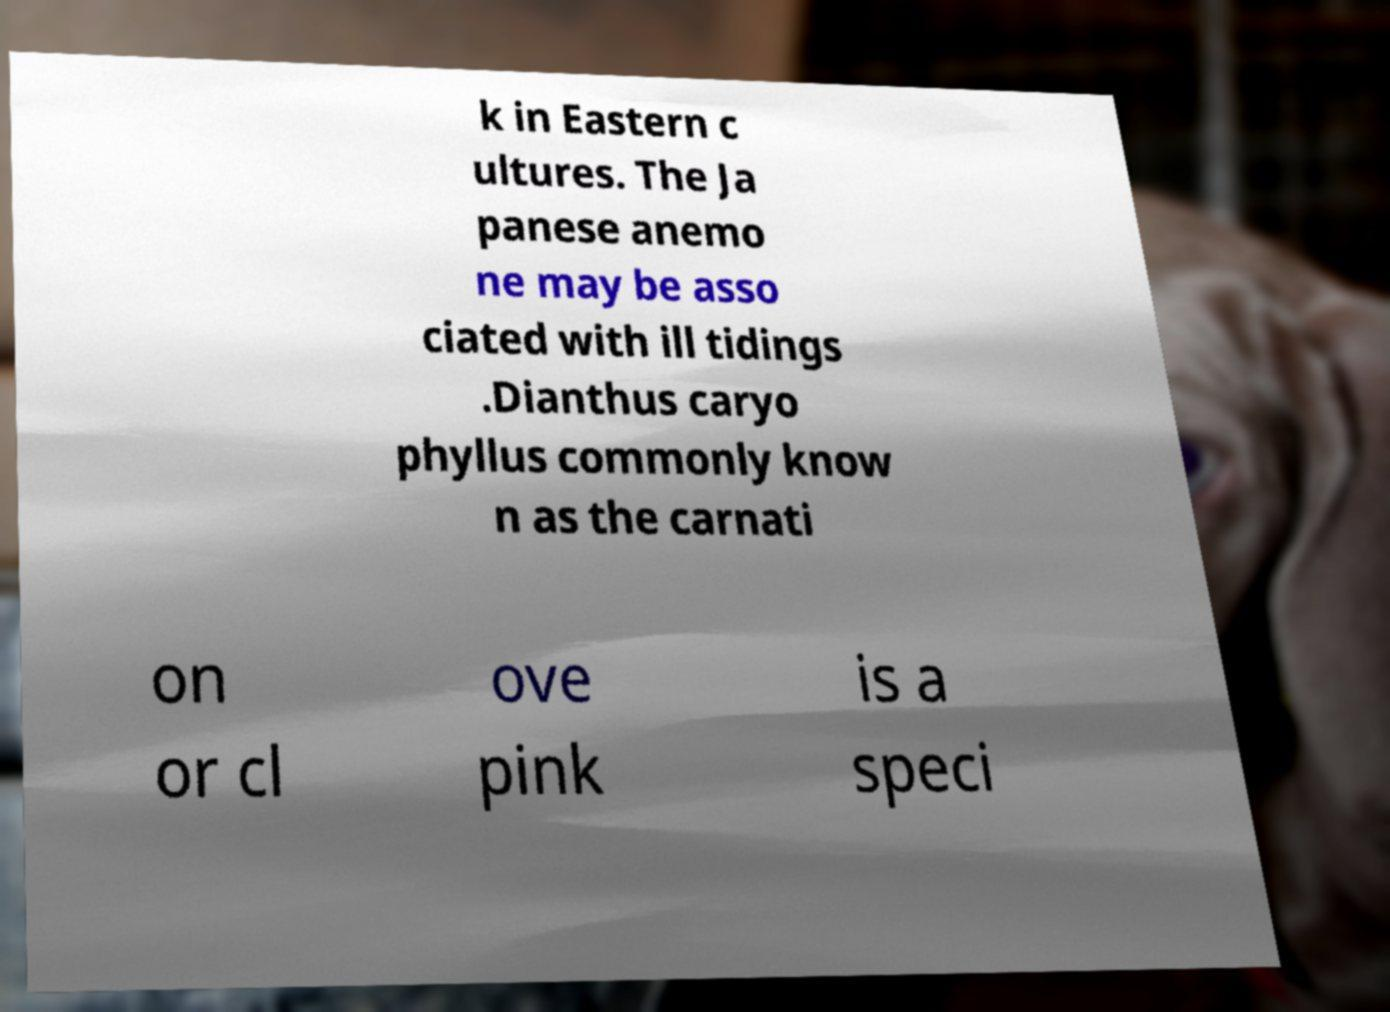What messages or text are displayed in this image? I need them in a readable, typed format. k in Eastern c ultures. The Ja panese anemo ne may be asso ciated with ill tidings .Dianthus caryo phyllus commonly know n as the carnati on or cl ove pink is a speci 